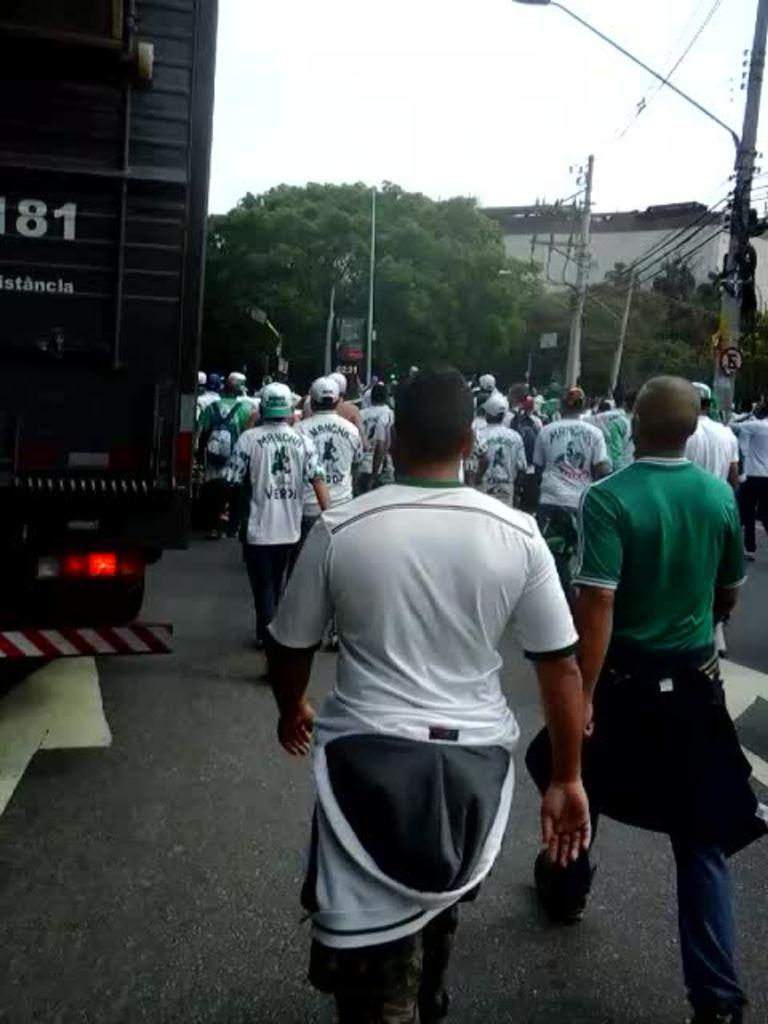Please provide a concise description of this image. In this picture I can see few people walking and few are wearing caps on their heads and I can see a man is wearing a backpack and I can see a truck on the left side and I can see few trees and a building and I can see few poles and a sky. 